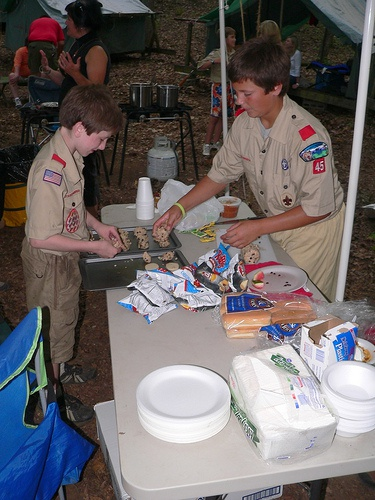Describe the objects in this image and their specific colors. I can see people in black and gray tones, dining table in black, darkgray, and lightgray tones, people in black, gray, and darkgray tones, chair in black, blue, darkblue, and navy tones, and people in black, maroon, and gray tones in this image. 